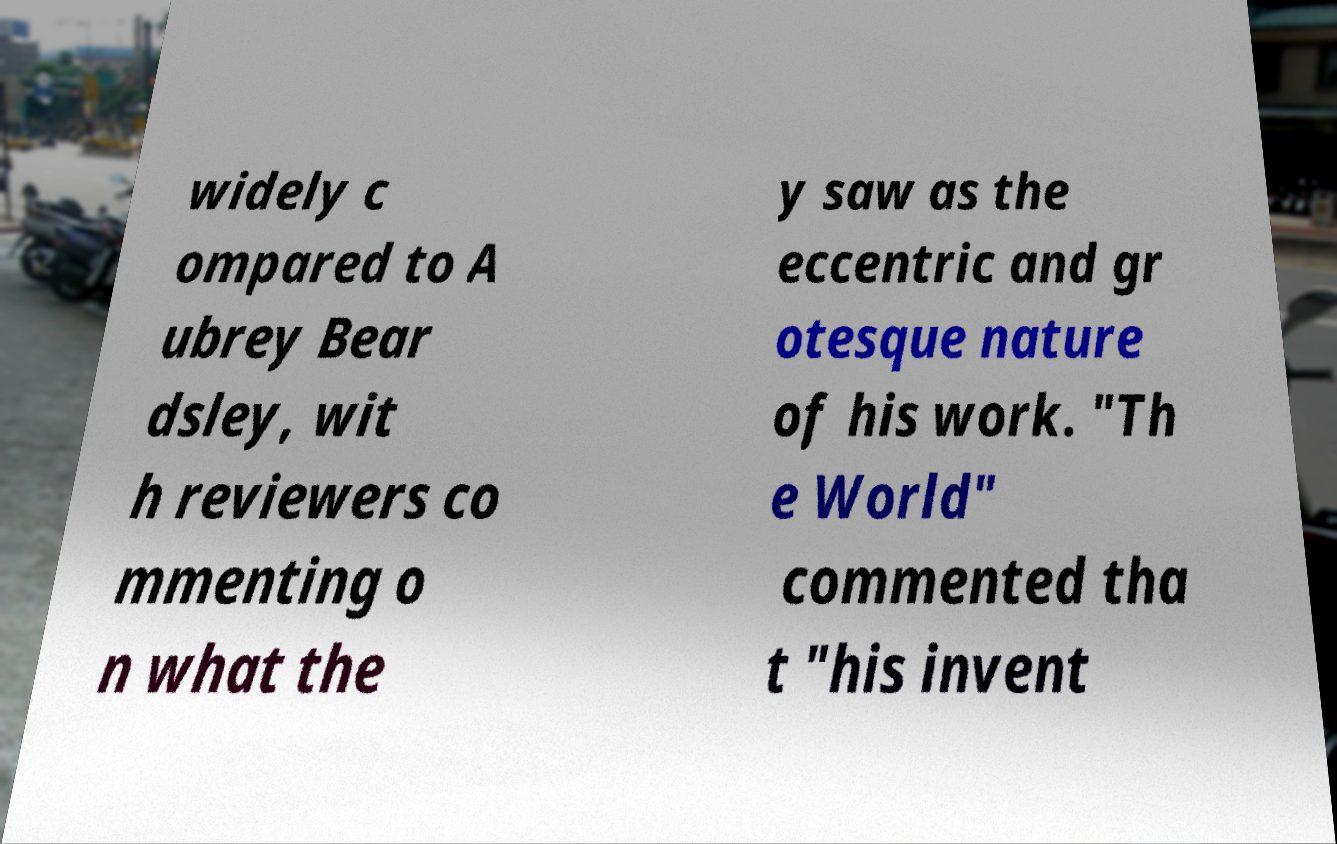I need the written content from this picture converted into text. Can you do that? widely c ompared to A ubrey Bear dsley, wit h reviewers co mmenting o n what the y saw as the eccentric and gr otesque nature of his work. "Th e World" commented tha t "his invent 